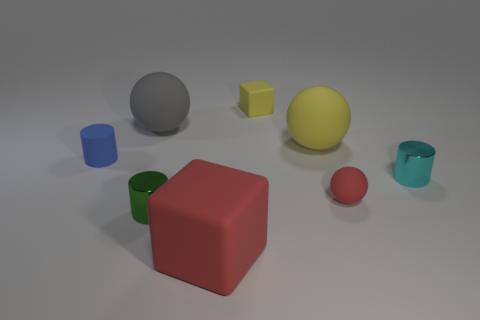Are there any rubber spheres of the same size as the cyan metal cylinder?
Your response must be concise. Yes. What number of brown objects are either big blocks or large rubber objects?
Your answer should be compact. 0. What number of small rubber things have the same color as the small sphere?
Provide a succinct answer. 0. Is there any other thing that has the same shape as the tiny blue object?
Provide a succinct answer. Yes. What number of cubes are small blue matte objects or small purple things?
Your response must be concise. 0. What color is the small cylinder that is to the right of the small matte block?
Offer a very short reply. Cyan. The gray object that is the same size as the yellow matte ball is what shape?
Ensure brevity in your answer.  Sphere. What number of tiny rubber objects are in front of the tiny cube?
Offer a terse response. 2. How many things are large brown matte cubes or tiny metallic things?
Ensure brevity in your answer.  2. The rubber thing that is right of the small green metallic cylinder and to the left of the small yellow rubber thing has what shape?
Make the answer very short. Cube. 